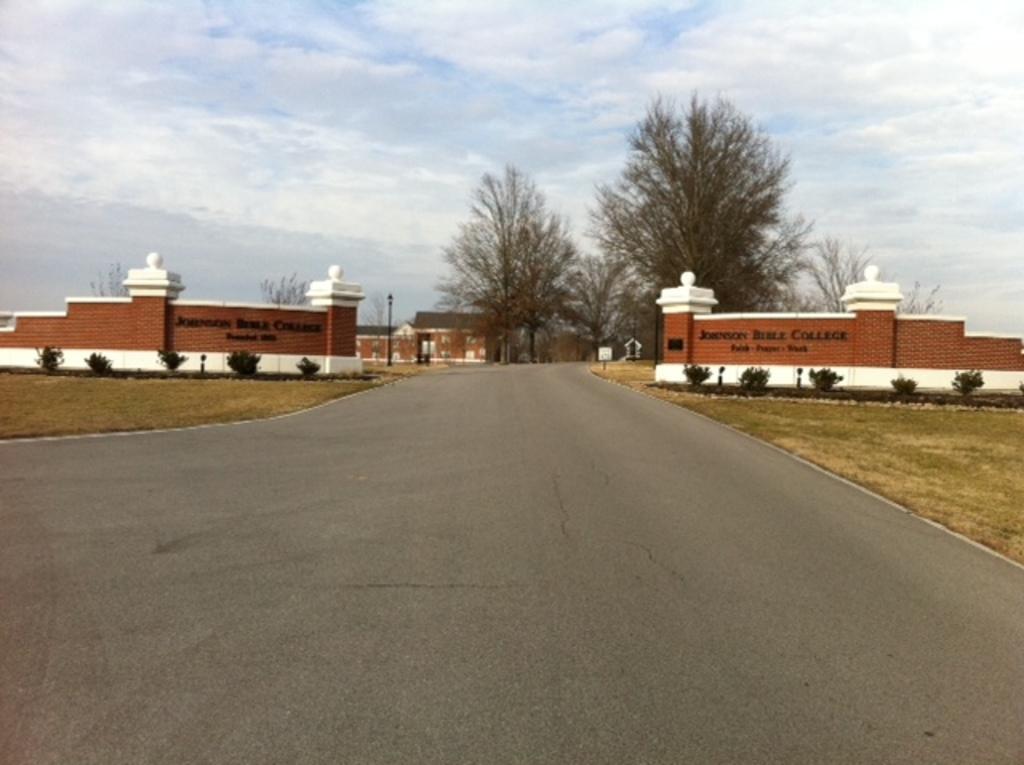Could you give a brief overview of what you see in this image? In this image there is a road, on either side of the road there is a land, in the background there is a wall and an entrance, trees and the sky. 